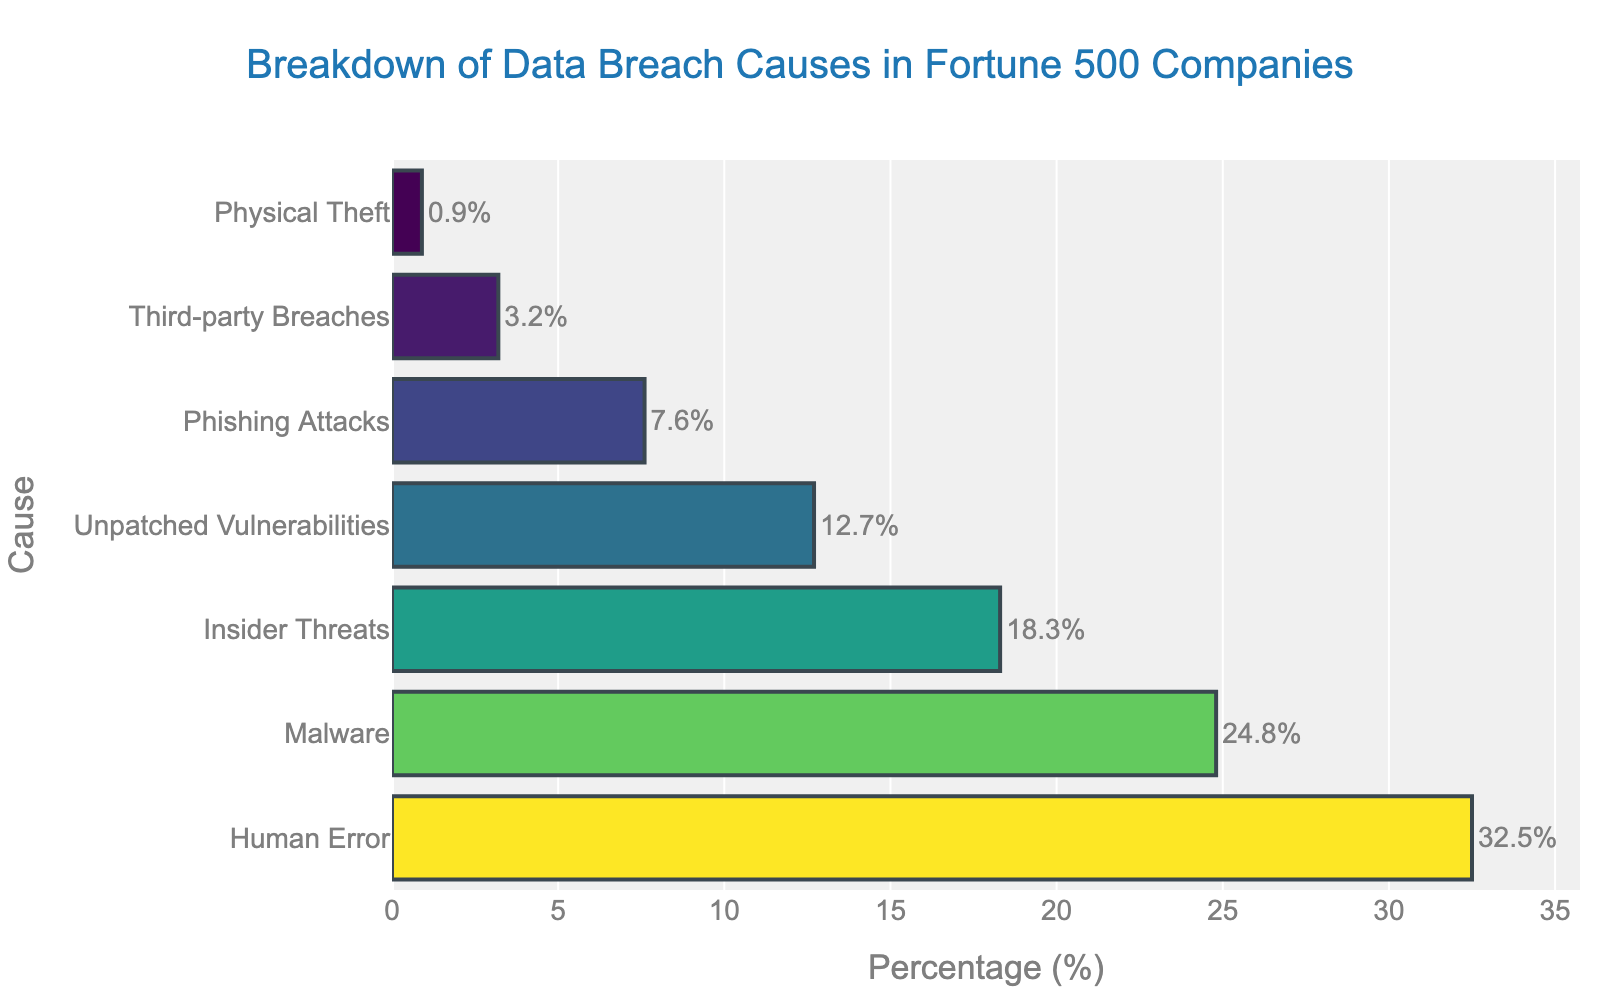What is the most common cause of data breaches according to the chart? The cause with the highest percentage is the most common. From the chart, the bar representing 'Human Error' has the highest percentage.
Answer: Human Error Which cause is responsible for almost a quarter of data breaches? To find the cause responsible for about 25% of data breaches, look for the bar close to 25%. 'Malware' is around 24.8%, which is nearly a quarter.
Answer: Malware How much higher is the percentage of data breaches caused by Human Error compared to Phishing Attacks? Subtract the percentage of Phishing Attacks from Human Error: 32.5 - 7.6 = 24.9.
Answer: 24.9 What's the total percentage of data breaches caused by Malware and Insider Threats combined? Sum the percentages of Malware and Insider Threats: 24.8 + 18.3 = 43.1.
Answer: 43.1 What percentage of data breaches is due to insider activities (Insider Threats and Third-party Breaches)? Add the percentages of Insider Threats and Third-party Breaches: 18.3 + 3.2 = 21.5.
Answer: 21.5 Which cause has the lowest percentage of data breaches, and what is the percentage? The bar with the smallest value represents the cause with the lowest percentage. 'Physical Theft' has the lowest percentage at 0.9%.
Answer: Physical Theft, 0.9 Is the percentage of data breaches caused by Unpatched Vulnerabilities greater than 10%? Compare the percentage of Unpatched Vulnerabilities to 10%. It is 12.7%, which is greater than 10%.
Answer: Yes Rank the causes of data breaches from most to least common. List the causes in descending order based on their percentages: Human Error (32.5), Malware (24.8), Insider Threats (18.3), Unpatched Vulnerabilities (12.7), Phishing Attacks (7.6), Third-party Breaches (3.2), Physical Theft (0.9).
Answer: Human Error, Malware, Insider Threats, Unpatched Vulnerabilities, Phishing Attacks, Third-party Breaches, Physical Theft Which has a higher percentage: Unpatched Vulnerabilities or Phishing Attacks? Compare the percentages of both causes. Unpatched Vulnerabilities have 12.7%, while Phishing Attacks have 7.6%. 12.7% is higher.
Answer: Unpatched Vulnerabilities What is the average percentage of data breaches caused by Human Error, Malware, and Insider Threats? Add the percentages and divide by 3: (32.5 + 24.8 + 18.3) / 3 = 75.6 / 3 = 25.2.
Answer: 25.2 